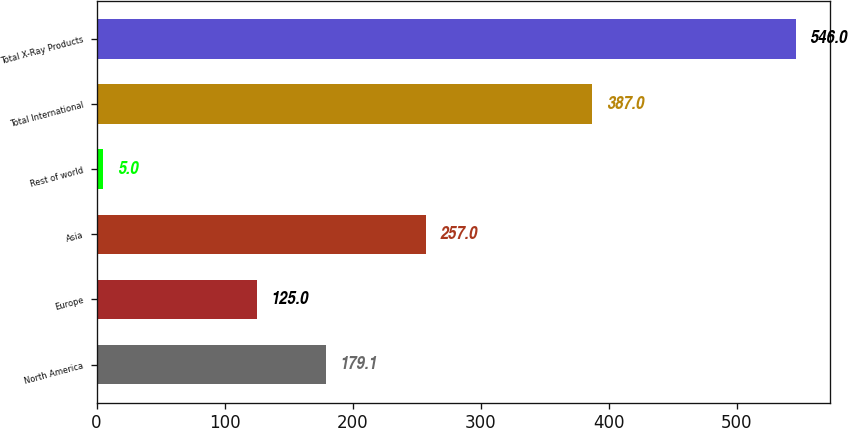<chart> <loc_0><loc_0><loc_500><loc_500><bar_chart><fcel>North America<fcel>Europe<fcel>Asia<fcel>Rest of world<fcel>Total International<fcel>Total X-Ray Products<nl><fcel>179.1<fcel>125<fcel>257<fcel>5<fcel>387<fcel>546<nl></chart> 